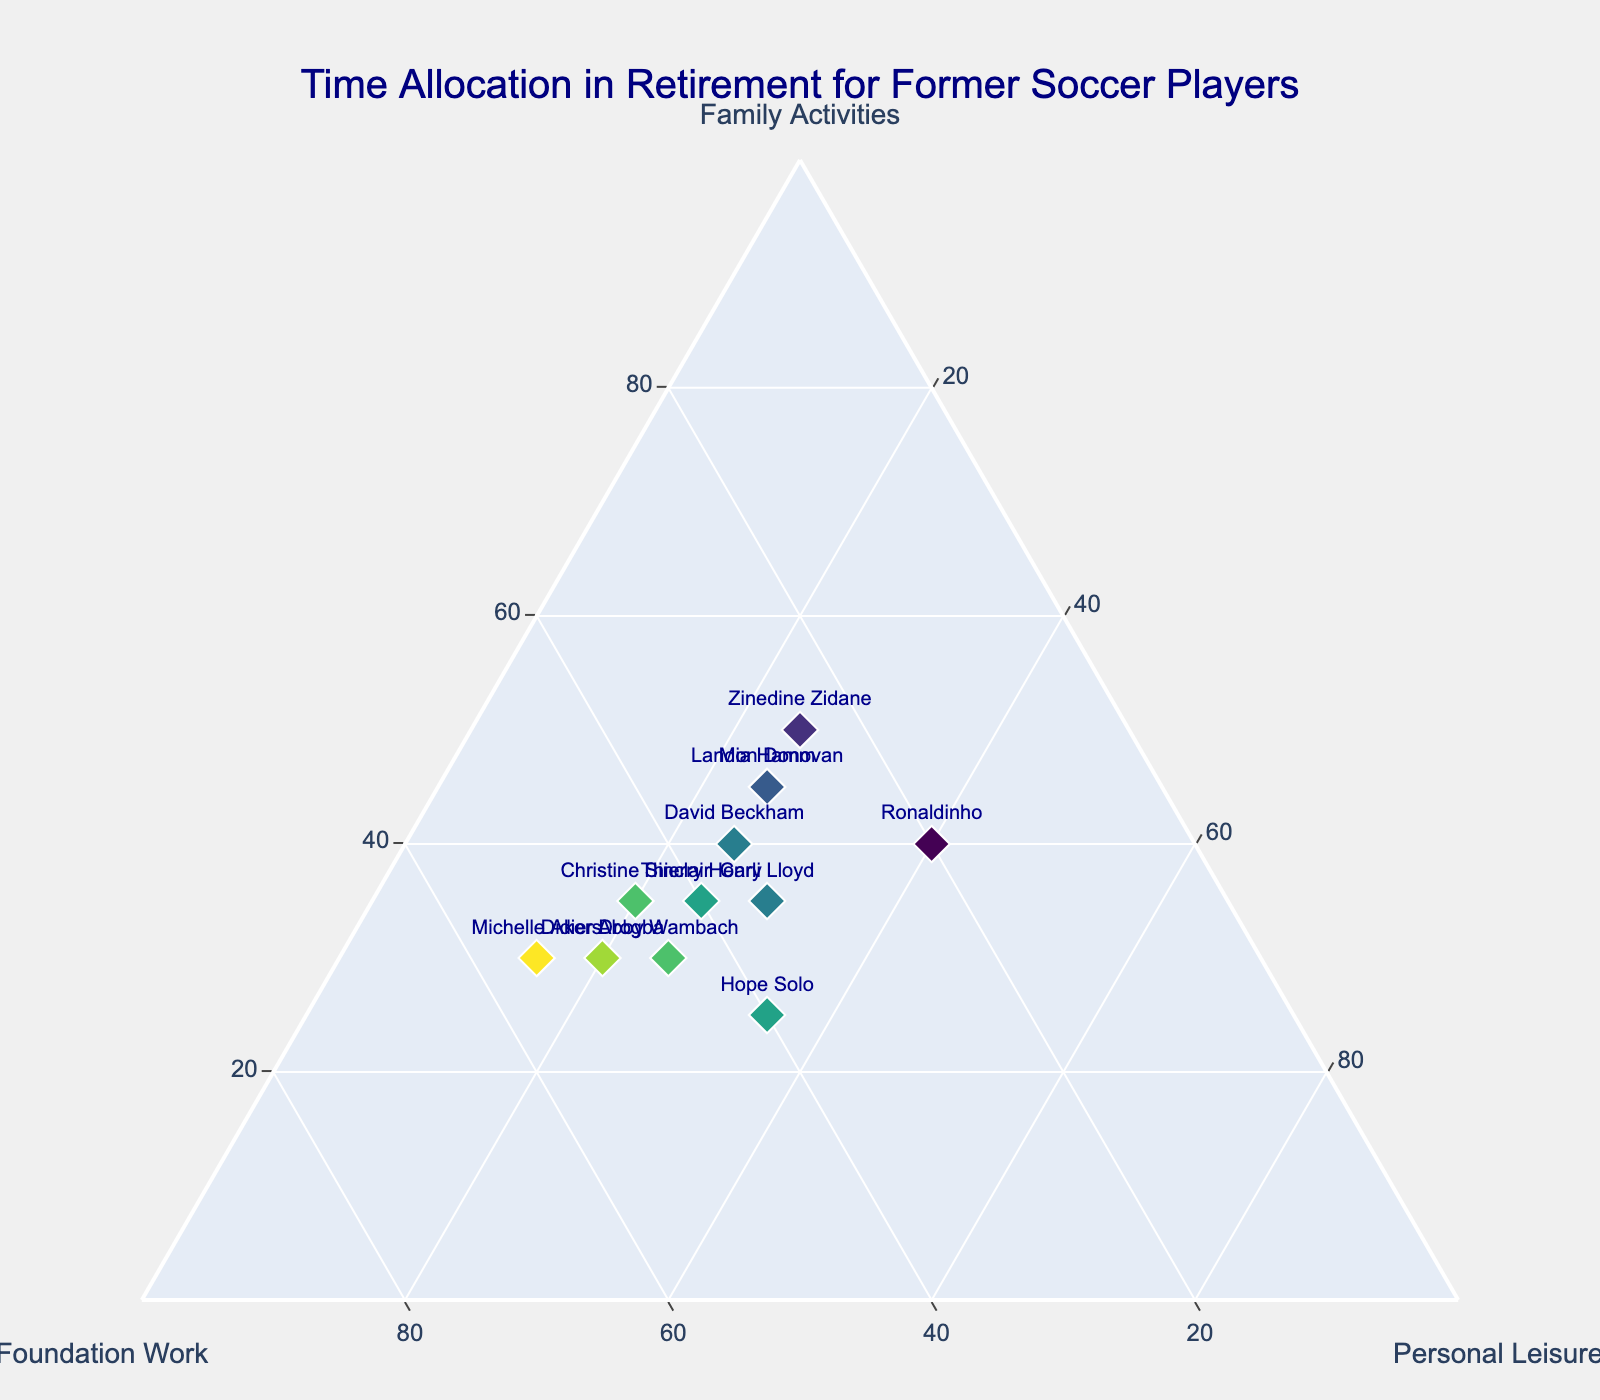What's the title of the figure? The title of the figure is shown at the top center in a larger font size. It is placed in a prominent position to catch the viewer's attention first.
Answer: "Time Allocation in Retirement for Former Soccer Players" How many data points are shown in the figure? Each data point corresponds to a former soccer player, and they are marked with diamond symbols. By counting these symbols or the number of names visible, you can determine the total count.
Answer: 12 What are the three main categories in the ternary plot? The main categories are indicated by the axis titles of the ternary plot, which encircle the triangular plot area.
Answer: Family Activities, Foundation Work, Personal Leisure Who spends the most amount of time on Foundation Work? For each data point, the time spent on Foundation Work is proportional to its position along the respective axis. The highest value on this axis is 55.
Answer: Michelle Akers What is the sum of time allocation for Hope Solo on Family Activities and Foundation Work? To find this sum, locate Hope Solo's marker on the plot and add the given percentage values for Family Activities and Foundation Work.
Answer: 25 + 40 = 65 Who spends an equal amount of time on all three activities? A balanced time allocation among Family Activities, Foundation Work, and Personal Leisure would place the corresponding data point at the center of the ternary plot, where the values for each activity are the same or very close.
Answer: No one Compare the time spent on Personal Leisure between Didier Drogba and Hope Solo. Who spends more? Refer to the values plotted along the Personal Leisure axis for both individuals and compare them directly.
Answer: Hope Solo Which former soccer player spends the least amount of time on Family Activities? The player with the smallest value on the Family Activities axis, as shown by the position of their marker along this axis, spends the least time.
Answer: Hope Solo Identify the player who spends the most time on Family Activities and the least on Foundation Work. By looking at the extremes of the Family Activities and Foundation Work axes, you can identify the player who fits both criteria.
Answer: Zinedine Zidane Which player has the highest combined time spent on Foundation Work and Personal Leisure? For each player, add the values from the Foundation Work and Personal Leisure axes, then identify the one with the highest total combined value.
Answer: Didier Drogba 